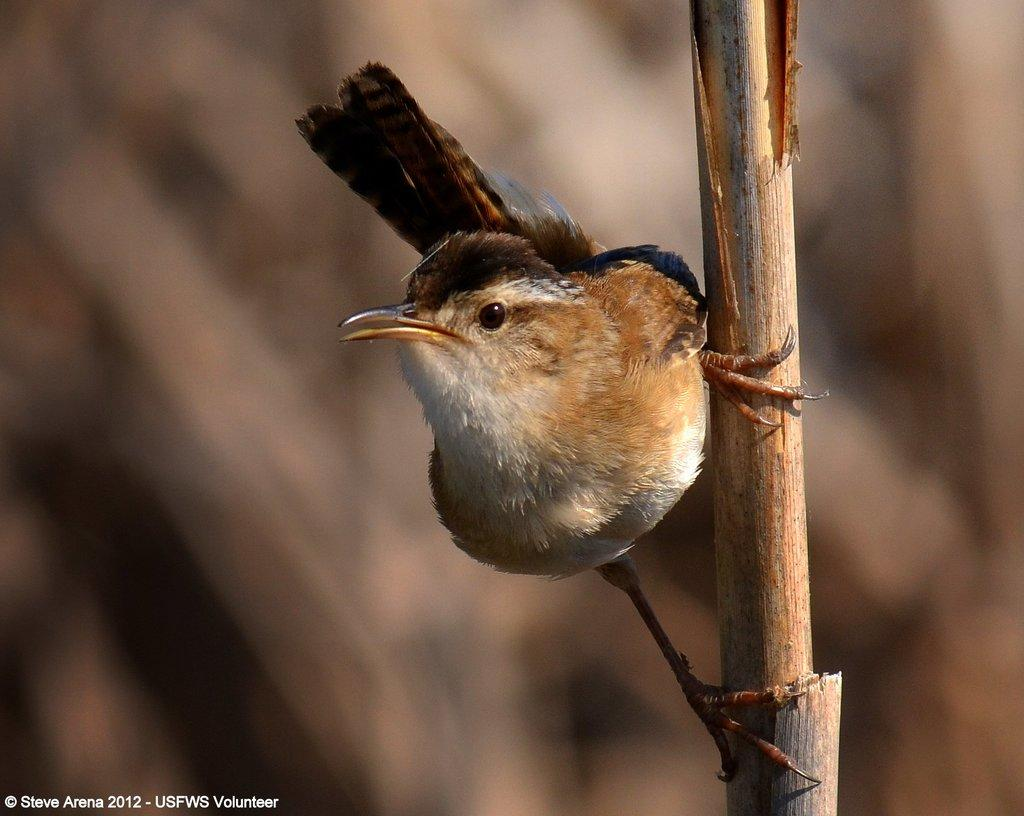What is the main object in the image? There is a stem in the image. What is on the stem? A bird is standing on the stem. What can be seen behind the bird? There is a blurred image behind the bird. Can you see a person wearing a coat in the image? There is no person or coat present in the image. 